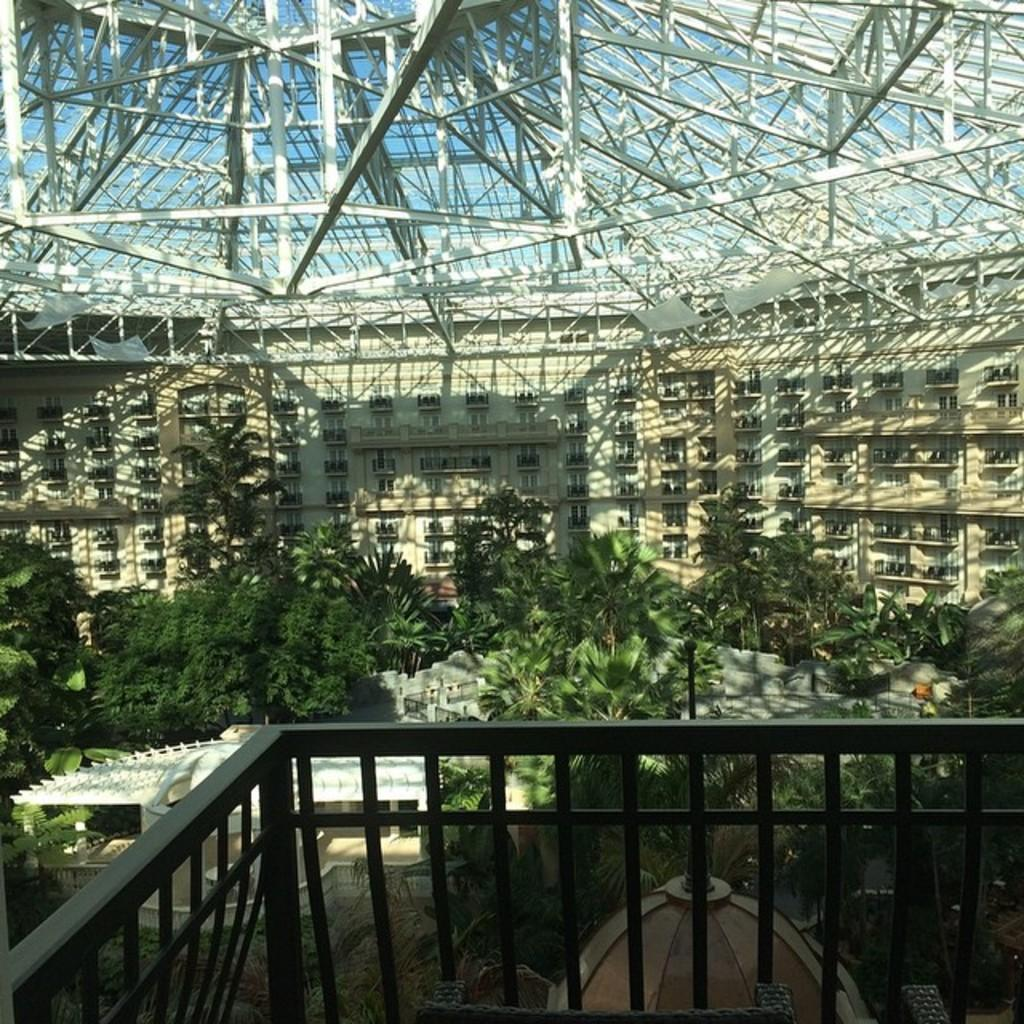What is the main structure in the image? There is a building in the middle of the image. What type of vegetation can be seen in the image? There are bushes and trees in the image. What is the tendency of pollution in the image? There is no information about pollution in the image, as it only features a building, bushes, and trees. 